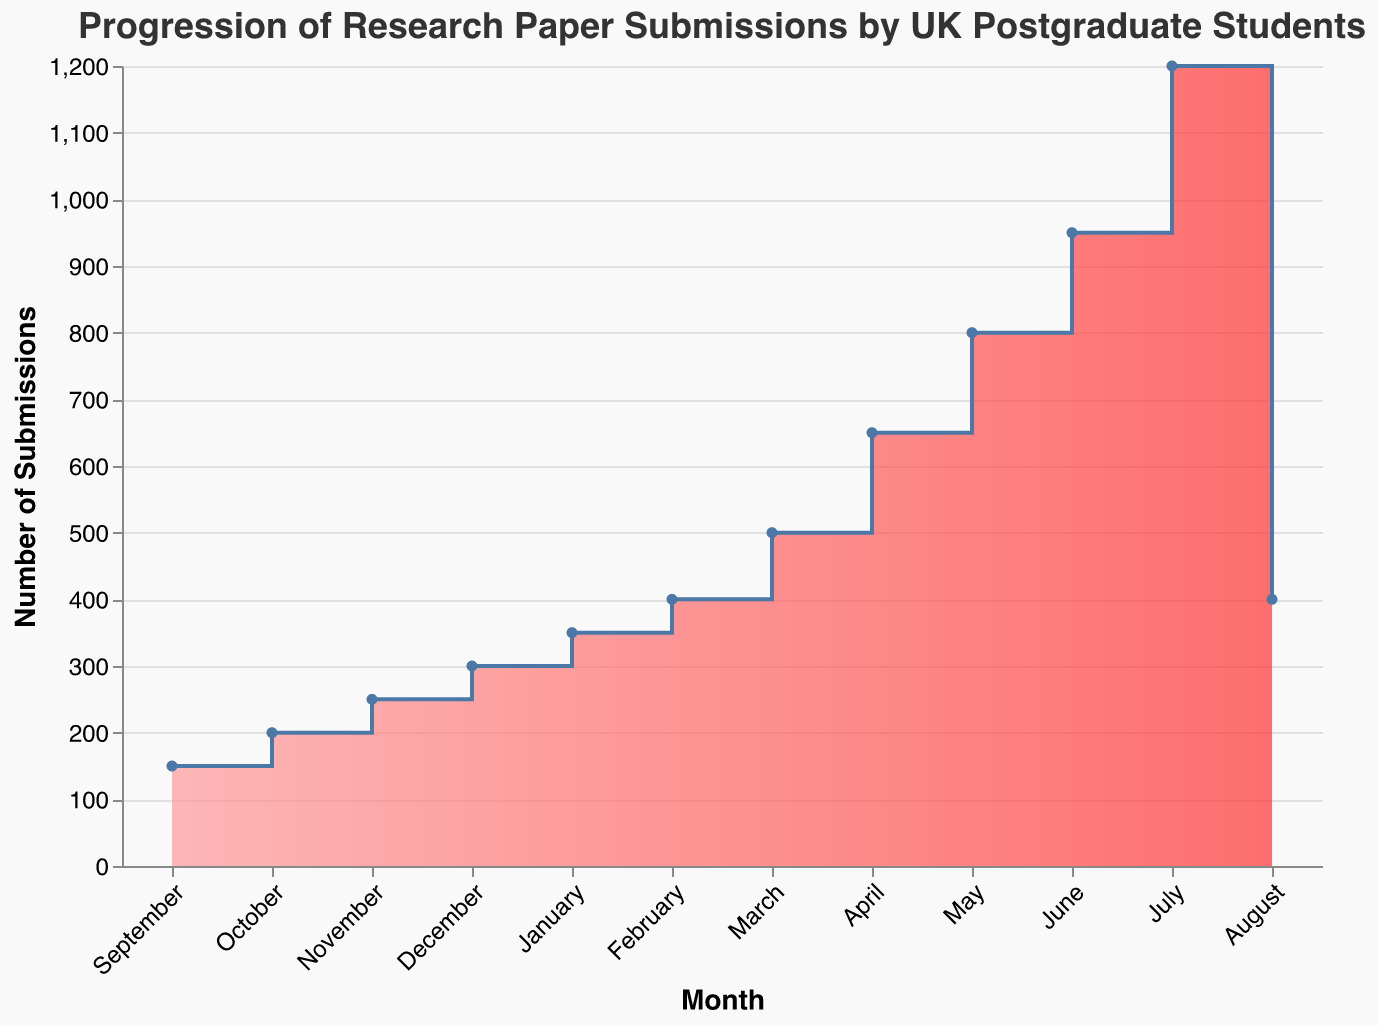What is the title of the chart? The title of the chart is located at the top and reads "Progression of Research Paper Submissions by UK Postgraduate Students".
Answer: Progression of Research Paper Submissions by UK Postgraduate Students Which month has the highest number of submissions? The peak of the graph occurs in July, where the number of submissions reaches 1200, the highest point on the chart.
Answer: July How many submissions were made in November? From the y-axis value for November, the number of submissions was 250.
Answer: 250 What is the difference in the number of submissions between January and February? January has 350 submissions, and February has 400 submissions. The difference is 400 - 350 = 50.
Answer: 50 In which months did the number of submissions exceed 600? Observing the y-axis values, the months with more than 600 submissions are May (800), June (950), and July (1200).
Answer: May, June, July Compare the submissions between March and April. Which month had more, and by how much? March had 500 submissions and April had 650. April had more submissions by 650 - 500 = 150.
Answer: April, by 150 What is the average number of submissions from September to December? Calculate the average by adding the submissions for those months and dividing by 4. (150 + 200 + 250 + 300) / 4 = 225.
Answer: 225 Which month experienced the steepest increase in submissions? By looking at the steepest rise in the area chart, the largest increase is between June and July, moving from 950 to 1200, an increase of 250 submissions.
Answer: Between June and July Describe the trend in submissions from September to July. Starting at 150 in September, submissions steadily increase each month, peaking at 1200 in July, indicating a general upward trend throughout the academic year.
Answer: Steady increase with a peak in July 